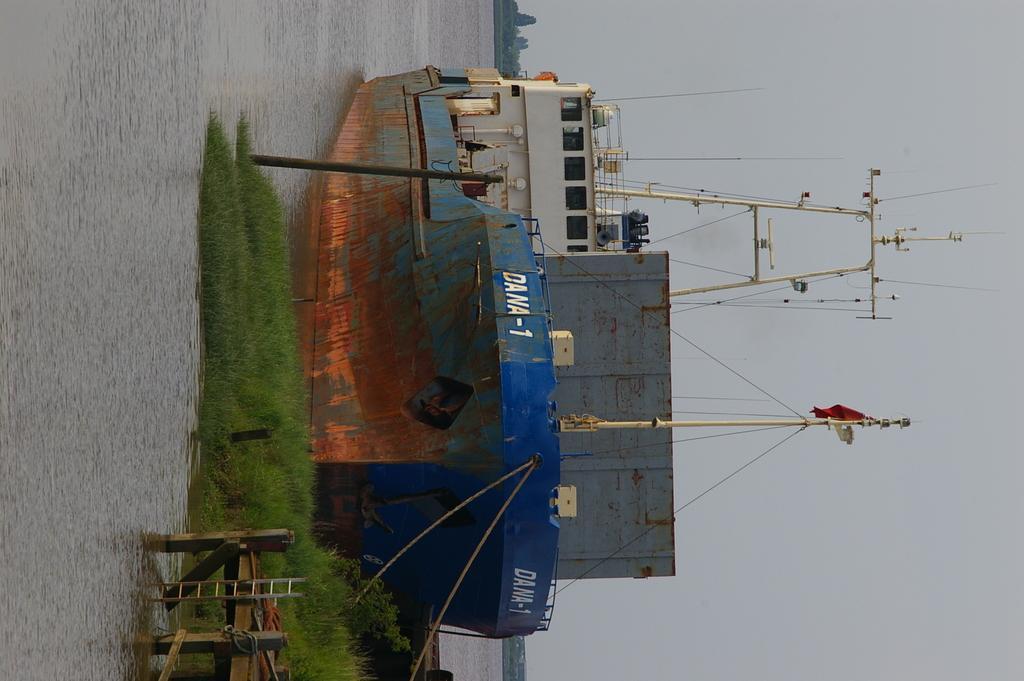In one or two sentences, can you explain what this image depicts? In this image we can see a ship with some poles, wires and the flag in a water body. We can also see some grass, plants, a wooden pole and a ladder on a deck. On the backside we can see a group of trees and the sky. 